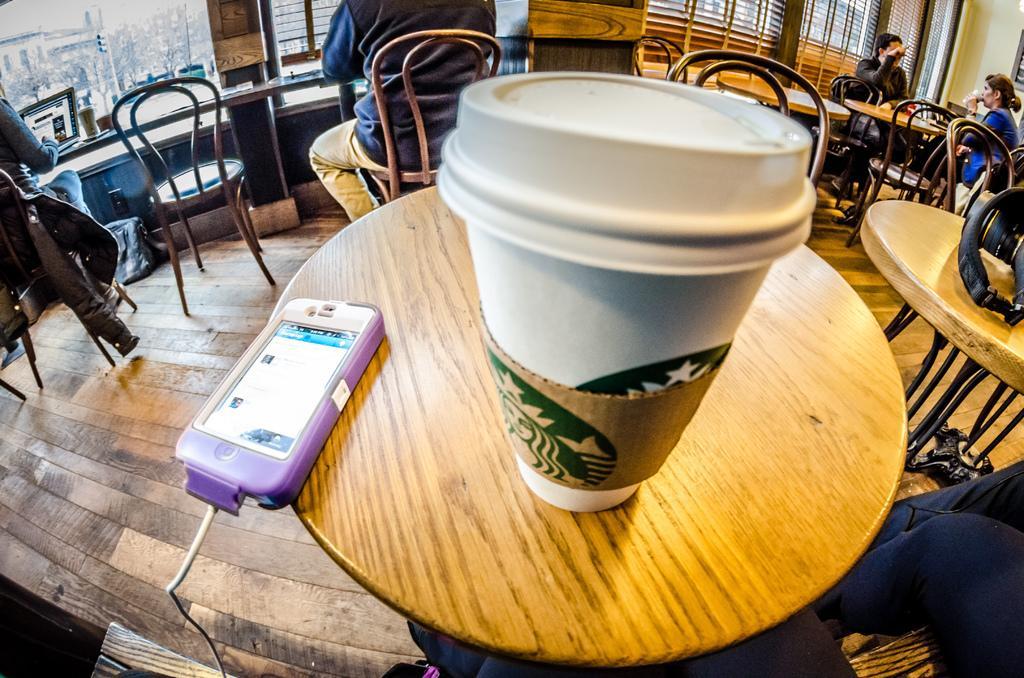Can you describe this image briefly? This picture shows a cup and a mobile on the table and we see few people seated on the chairs 